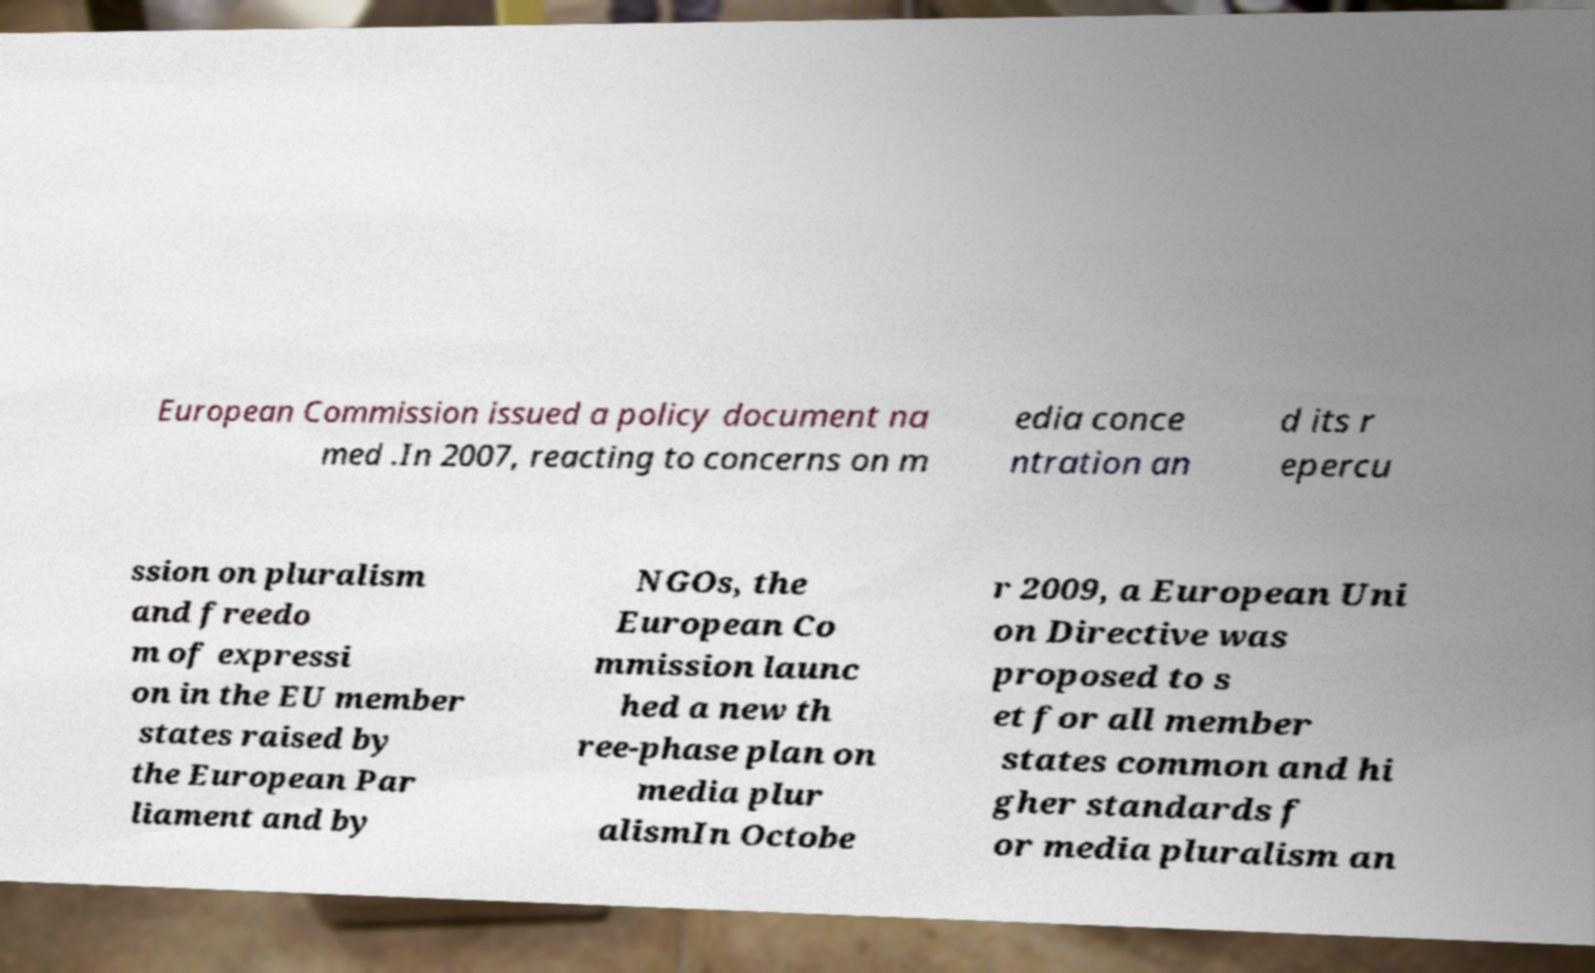Could you assist in decoding the text presented in this image and type it out clearly? European Commission issued a policy document na med .In 2007, reacting to concerns on m edia conce ntration an d its r epercu ssion on pluralism and freedo m of expressi on in the EU member states raised by the European Par liament and by NGOs, the European Co mmission launc hed a new th ree-phase plan on media plur alismIn Octobe r 2009, a European Uni on Directive was proposed to s et for all member states common and hi gher standards f or media pluralism an 